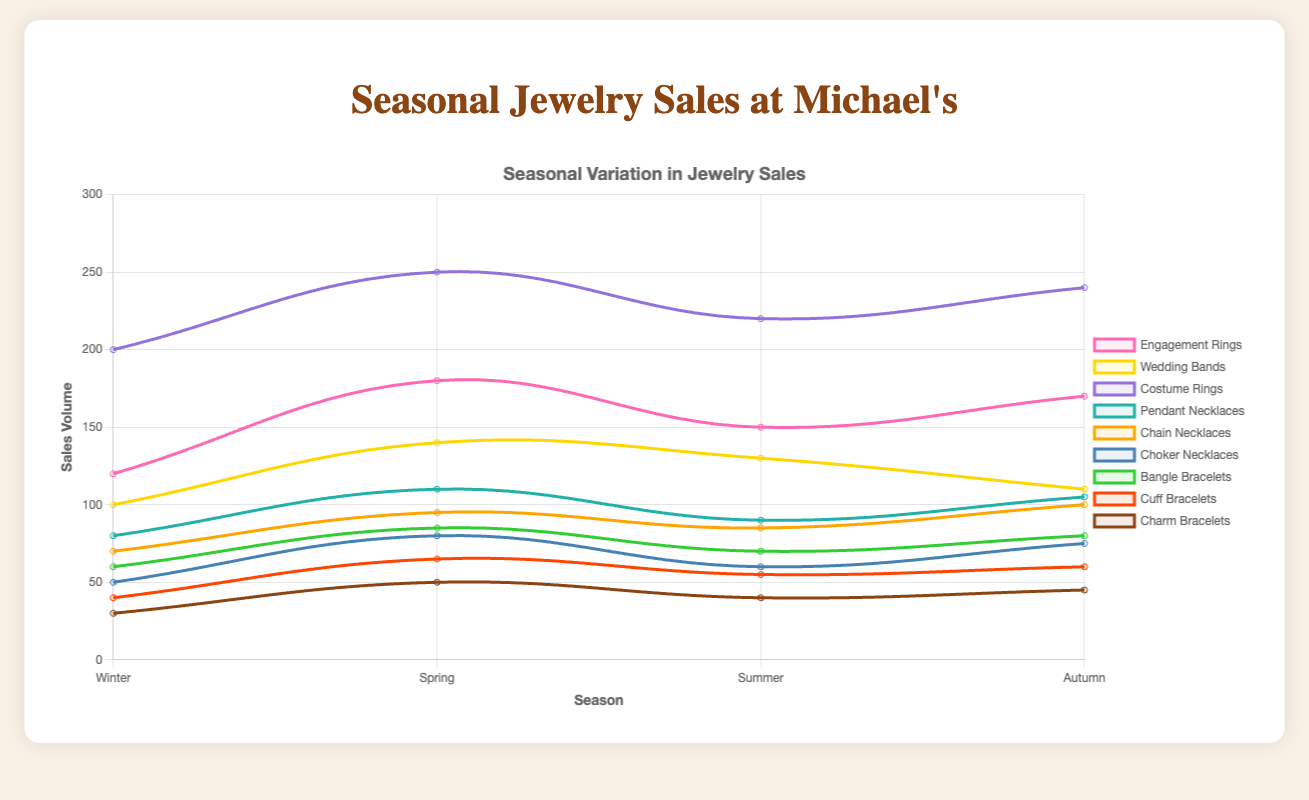What season has the highest sales volume for costume rings? The data for costume rings is [200, 250, 220, 240], with the highest value being 250 in Spring.
Answer: Spring Which type of jewelry has the lowest sales volume in Winter? Comparing the winter data for all jewelry: Engagement Rings (120), Wedding Bands (100), Costume Rings (200), Pendant Necklaces (80), Chain Necklaces (70), Choker Necklaces (50), Bangle Bracelets (60), Cuff Bracelets (40), Charm Bracelets (30), the lowest value is Charm Bracelets with 30.
Answer: Charm Bracelets What is the total sales volume of cuff bracelets throughout all seasons? Summing up the sales data for Cuff Bracelets across all seasons: 40 (Winter) + 65 (Spring) + 55 (Summer) + 60 (Autumn) = 220.
Answer: 220 What season has the highest average sales volume for rings (engagement, wedding bands, costume)? First, find the average for each season:
Winter: (120 + 100 + 200) / 3 = 420 / 3 = 140
Spring: (180 + 140 + 250) / 3 = 570 / 3 = 190
Summer: (150 + 130 + 220) / 3 = 500 / 3 ≈ 166.67
Autumn: (170 + 110 + 240) / 3 = 520 / 3 ≈ 173.33
The highest average is in Spring with approximately 190.
Answer: Spring By how much do engagement ring sales differ between the highest and lowest seasons? The engagement ring sales data are [120, 180, 150, 170]. The highest value is 180 (Spring) and the lowest is 120 (Winter). The difference is 180 - 120 = 60.
Answer: 60 Which type of necklace shows the most consistent sales volume across seasons? Calculating the range (max - min sales) for each necklace type:
Pendant Necklaces range: 110 - 80 = 30
Chain Necklaces range: 100 - 70 = 30
Choker Necklaces range: 80 - 50 = 30
All have the same range, indicating consistent sales.
Answer: All types Compare the sales volumes of bangle bracelets and choker necklaces in Summer. Which one is higher? In Summer, Bangle Bracelets have a sales volume of 70, and Choker Necklaces have 60. Bangle Bracelets' sales are higher.
Answer: Bangle Bracelets What is the overall average sales volume for all types of jewelry in Autumn? Summing up the Autumn sales data for all types of jewelry:
170 (Engagement Rings) + 110 (Wedding Bands) + 240 (Costume Rings) + 105 (Pendant Necklaces) + 100 (Chain Necklaces) + 75 (Choker Necklaces) + 80 (Bangle Bracelets) + 60 (Cuff Bracelets) + 45 (Charm Bracelets) = 985
Average = 985 / 9 ≈ 109.44
Answer: Approximately 109.44 